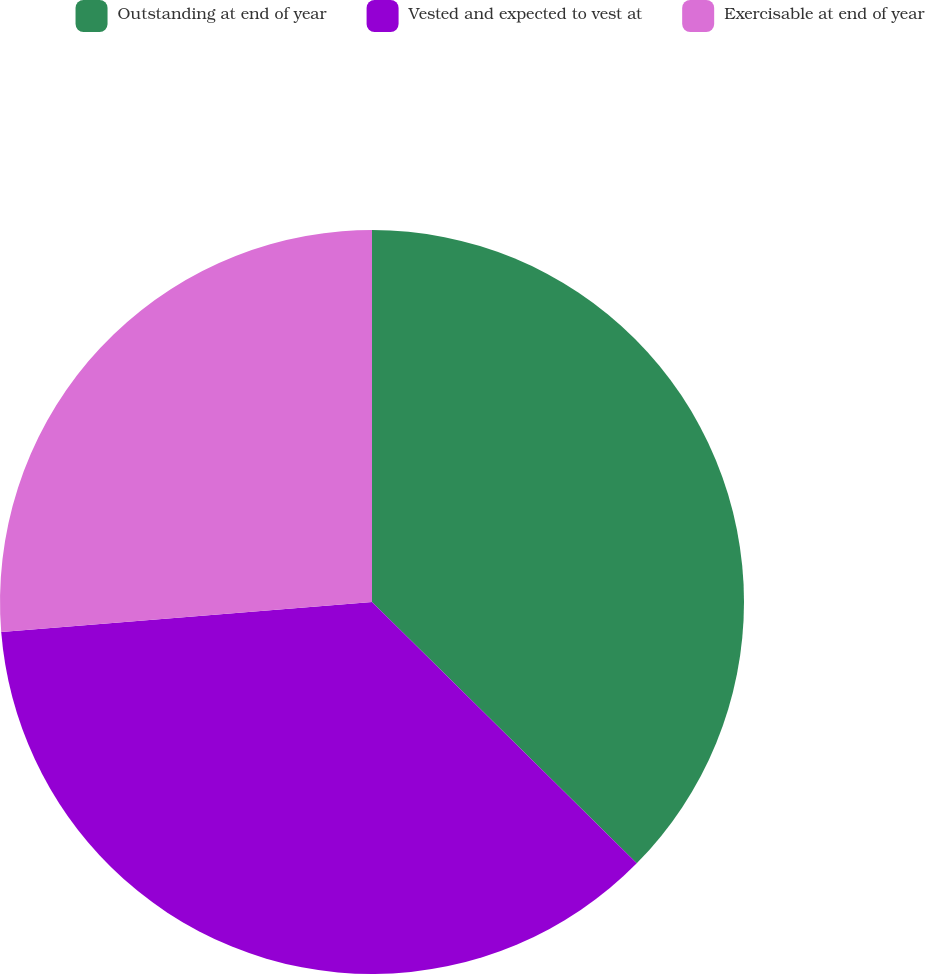Convert chart to OTSL. <chart><loc_0><loc_0><loc_500><loc_500><pie_chart><fcel>Outstanding at end of year<fcel>Vested and expected to vest at<fcel>Exercisable at end of year<nl><fcel>37.4%<fcel>36.32%<fcel>26.29%<nl></chart> 